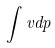<formula> <loc_0><loc_0><loc_500><loc_500>\int v d p</formula> 